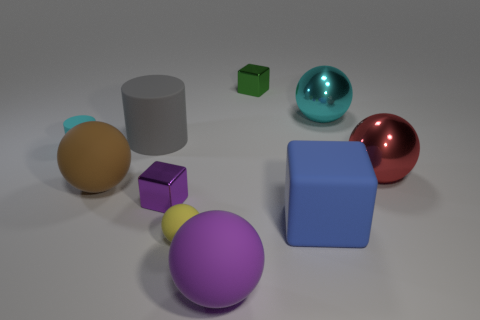Subtract all metal spheres. How many spheres are left? 3 Subtract all red spheres. How many spheres are left? 4 Subtract all cylinders. How many objects are left? 8 Subtract all yellow blocks. Subtract all brown spheres. How many blocks are left? 3 Subtract all small red balls. Subtract all small cyan rubber cylinders. How many objects are left? 9 Add 7 blue cubes. How many blue cubes are left? 8 Add 6 brown objects. How many brown objects exist? 7 Subtract 0 yellow cylinders. How many objects are left? 10 